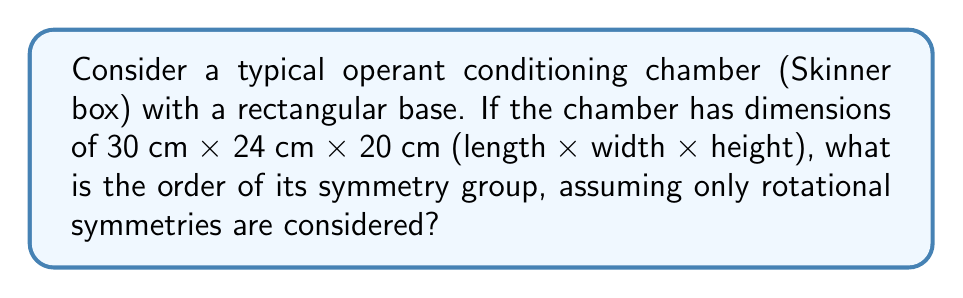Could you help me with this problem? To solve this problem, we need to follow these steps:

1) First, recall that the symmetry group of an object consists of all transformations that leave the object unchanged. In this case, we're only considering rotational symmetries.

2) The Skinner box is a rectangular prism. Let's analyze its rotational symmetries:

   - It has 2-fold rotational symmetry around the x-axis (length)
   - It has 2-fold rotational symmetry around the y-axis (width)
   - It has 2-fold rotational symmetry around the z-axis (height)

3) Each of these rotations, along with the identity transformation (no rotation), form the symmetry group of the Skinner box.

4) In group theory, this symmetry group is isomorphic to the Klein four-group, denoted as $V_4$ or $C_2 \times C_2$.

5) The elements of this group can be represented as:
   
   $$\{e, r_x, r_y, r_z\}$$

   where $e$ is the identity transformation, and $r_x$, $r_y$, and $r_z$ are 180° rotations around the x, y, and z axes respectively.

6) The order of a group is the number of elements in the group. In this case, we have 4 elements.

Therefore, the order of the symmetry group of the Skinner box, considering only rotational symmetries, is 4.
Answer: 4 